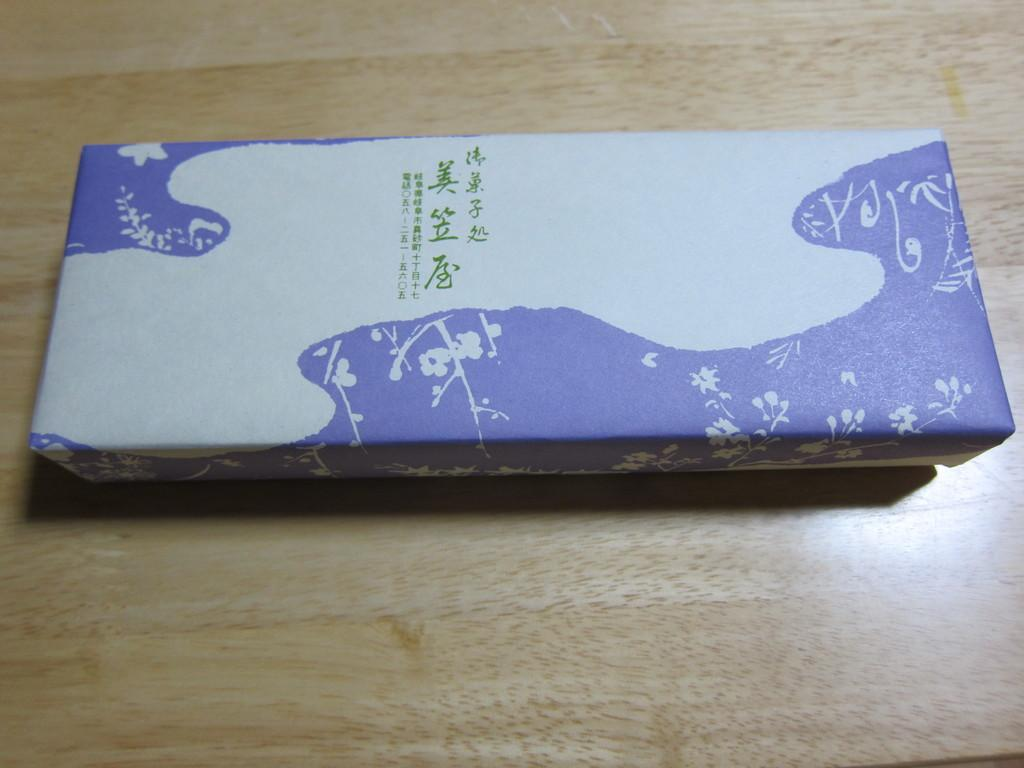What is the main object in the image? There is a box in the image. What is the box placed on? The box is on a wooden object. How many ladybugs can be seen crawling on the box in the image? There are no ladybugs present in the image. What type of pig is sitting next to the box in the image? There is no pig present in the image. 